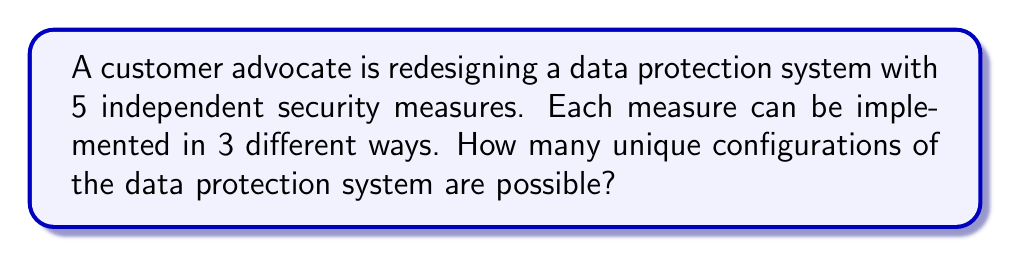Give your solution to this math problem. Let's approach this step-by-step:

1) We have 5 independent security measures, each of which can be implemented in 3 different ways.

2) This scenario is a perfect application of the Multiplication Principle in combinatorics.

3) The Multiplication Principle states that if we have $n$ independent events, and each event $i$ can occur in $m_i$ ways, then the total number of ways all events can occur is the product of all $m_i$.

4) In this case, we have 5 events (the security measures), and each can occur in 3 ways.

5) Therefore, the total number of unique configurations is:

   $$3 \times 3 \times 3 \times 3 \times 3 = 3^5$$

6) We can calculate this:

   $$3^5 = 3 \times 3 \times 3 \times 3 \times 3 = 243$$

Thus, there are 243 unique ways to configure the data protection system.
Answer: 243 